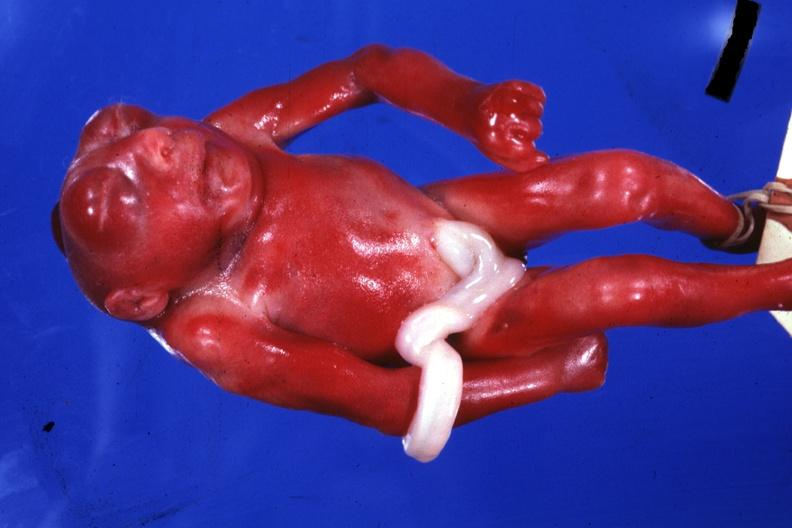s liver with tuberculoid granuloma in glissons present?
Answer the question using a single word or phrase. No 